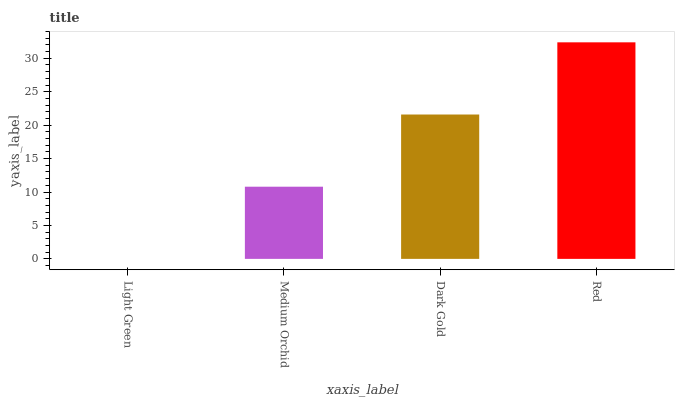Is Light Green the minimum?
Answer yes or no. Yes. Is Red the maximum?
Answer yes or no. Yes. Is Medium Orchid the minimum?
Answer yes or no. No. Is Medium Orchid the maximum?
Answer yes or no. No. Is Medium Orchid greater than Light Green?
Answer yes or no. Yes. Is Light Green less than Medium Orchid?
Answer yes or no. Yes. Is Light Green greater than Medium Orchid?
Answer yes or no. No. Is Medium Orchid less than Light Green?
Answer yes or no. No. Is Dark Gold the high median?
Answer yes or no. Yes. Is Medium Orchid the low median?
Answer yes or no. Yes. Is Light Green the high median?
Answer yes or no. No. Is Red the low median?
Answer yes or no. No. 